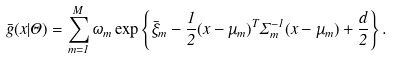Convert formula to latex. <formula><loc_0><loc_0><loc_500><loc_500>\bar { g } ( x | \Theta ) = \sum _ { m = 1 } ^ { M } \omega _ { m } \exp \left \{ \bar { \xi } _ { m } - \frac { 1 } { 2 } ( x - \mu _ { m } ) ^ { T } \Sigma _ { m } ^ { - 1 } ( x - \mu _ { m } ) + \frac { d } { 2 } \right \} .</formula> 